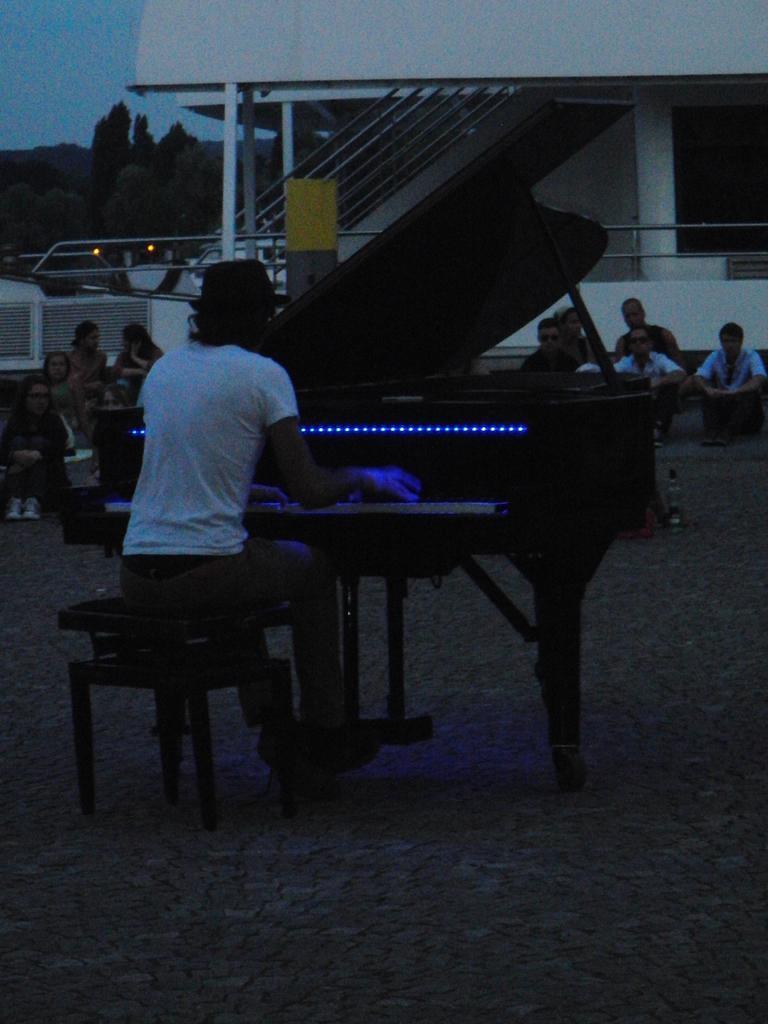Could you give a brief overview of what you see in this image? In this picture we can see man playing piano sitting on stool and in background we can see some people listening to his music, steps, building, pillar, trees. 